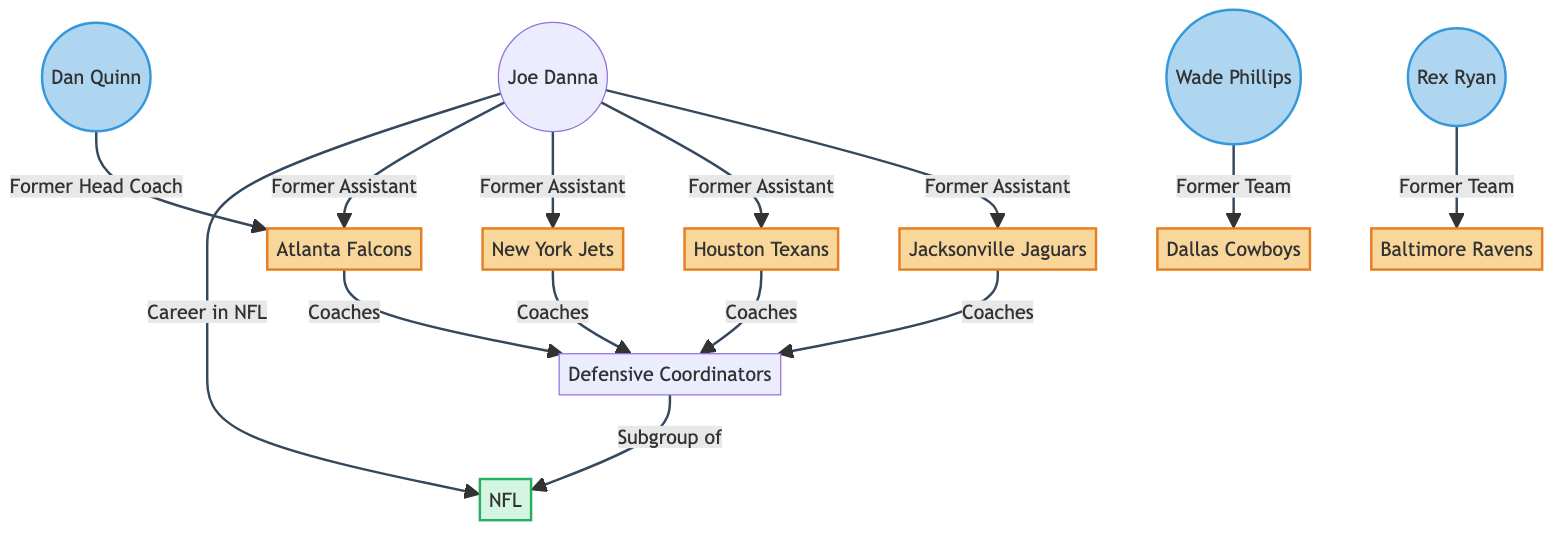What is Joe Danna's current team? The diagram does not specify Joe Danna's current team, as it primarily shows his former assistant roles. However, it does indicate his connections with various teams.
Answer: None How many teams has Joe Danna worked with as a former assistant? By counting the edges leading from Joe Danna to teams, you can see there are four connections to Jacksonville Jaguars, Houston Texans, New York Jets, and Atlanta Falcons.
Answer: 4 Which team did Coach A (Wade Phillips) work with? The edge from Coach A leads to the Dallas Cowboys, indicating that he worked there.
Answer: Dallas Cowboys Who is the former head coach of the Atlanta Falcons listed? The edge from Coach C (Dan Quinn) to the Atlanta Falcons indicates that Dan Quinn was the former head coach.
Answer: Dan Quinn Which teams are part of the defensive coordinators subgroup? The teams shown with edges connecting to the Defensive Coordinators node are Jacksonville Jaguars, Houston Texans, New York Jets, and Atlanta Falcons, which collectively indicates their involvement.
Answer: Jacksonville Jaguars, Houston Texans, New York Jets, Atlanta Falcons How many coaches are listed in the network diagram? The diagram displays three coaches: Wade Phillips, Rex Ryan, and Dan Quinn, indicating a small group of notable coaches in defensive roles.
Answer: 3 To which major league do the defensive coordinators belong? The diagram shows a direct edge from the Defensive Coordinators node to the National Football League, indicating their affiliation.
Answer: NFL Which team is associated with the most former assistants in the diagram? Since all four teams connected to Joe Danna each indicate his role as a former assistant, no single team is specifically highlighted with more connections in this context; rather, all four signify the same level of association with Joe Danna.
Answer: None Is "Former Assistant" the only relationship shown for Joe Danna? Examining the edges reveals that "Career in NFL" is also connected to the National Football League, thus indicating more than just former assistant roles.
Answer: No 